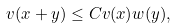<formula> <loc_0><loc_0><loc_500><loc_500>v ( x + y ) \leq C v ( x ) w ( y ) ,</formula> 